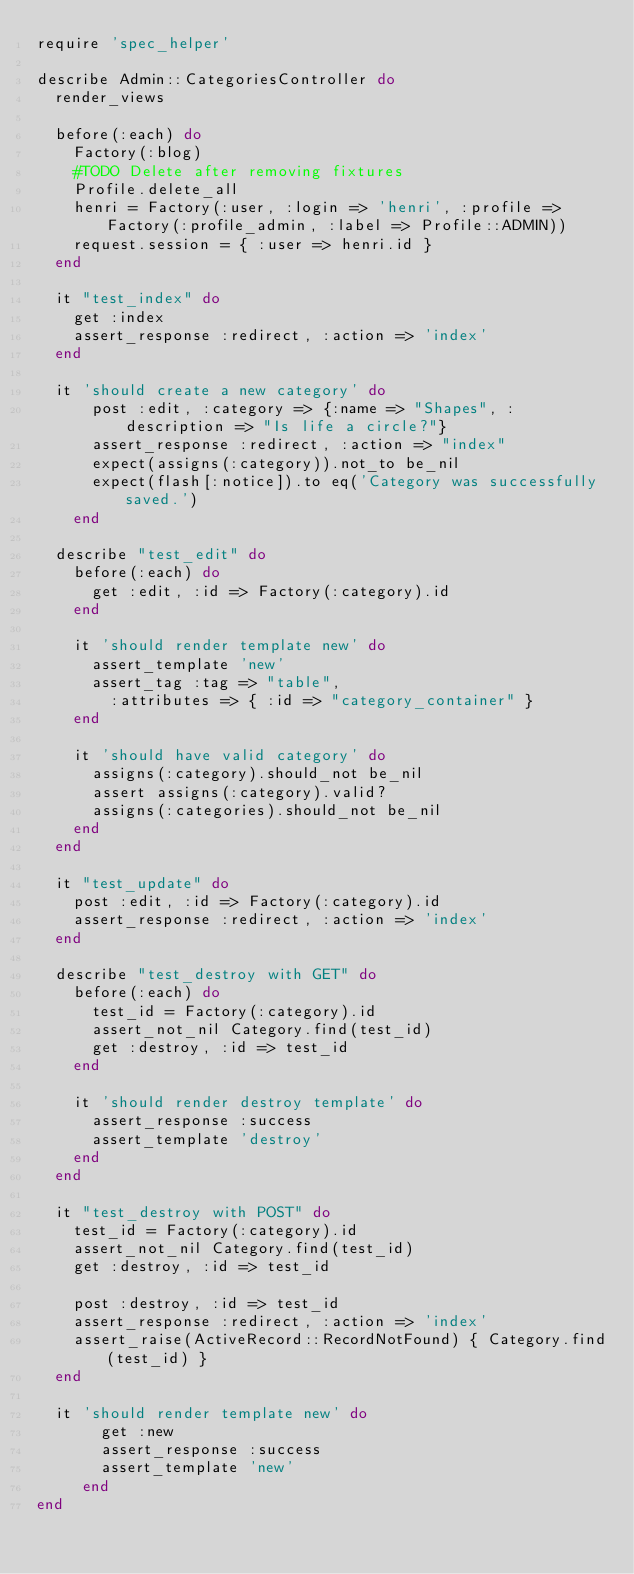Convert code to text. <code><loc_0><loc_0><loc_500><loc_500><_Ruby_>require 'spec_helper'

describe Admin::CategoriesController do
  render_views

  before(:each) do
    Factory(:blog)
    #TODO Delete after removing fixtures
    Profile.delete_all
    henri = Factory(:user, :login => 'henri', :profile => Factory(:profile_admin, :label => Profile::ADMIN))
    request.session = { :user => henri.id }
  end

  it "test_index" do
    get :index
    assert_response :redirect, :action => 'index'
  end
  
  it 'should create a new category' do
      post :edit, :category => {:name => "Shapes", :description => "Is life a circle?"}
      assert_response :redirect, :action => "index"
      expect(assigns(:category)).not_to be_nil
      expect(flash[:notice]).to eq('Category was successfully saved.')
    end

  describe "test_edit" do
    before(:each) do
      get :edit, :id => Factory(:category).id
    end

    it 'should render template new' do
      assert_template 'new'
      assert_tag :tag => "table",
        :attributes => { :id => "category_container" }
    end

    it 'should have valid category' do
      assigns(:category).should_not be_nil
      assert assigns(:category).valid?
      assigns(:categories).should_not be_nil
    end
  end

  it "test_update" do
    post :edit, :id => Factory(:category).id
    assert_response :redirect, :action => 'index'
  end

  describe "test_destroy with GET" do
    before(:each) do
      test_id = Factory(:category).id
      assert_not_nil Category.find(test_id)
      get :destroy, :id => test_id
    end

    it 'should render destroy template' do
      assert_response :success
      assert_template 'destroy'      
    end
  end

  it "test_destroy with POST" do
    test_id = Factory(:category).id
    assert_not_nil Category.find(test_id)
    get :destroy, :id => test_id

    post :destroy, :id => test_id
    assert_response :redirect, :action => 'index'
    assert_raise(ActiveRecord::RecordNotFound) { Category.find(test_id) }
  end
  
  it 'should render template new' do
       get :new
       assert_response :success
       assert_template 'new'
     end
end
</code> 